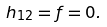<formula> <loc_0><loc_0><loc_500><loc_500>h _ { 1 2 } = f = 0 .</formula> 